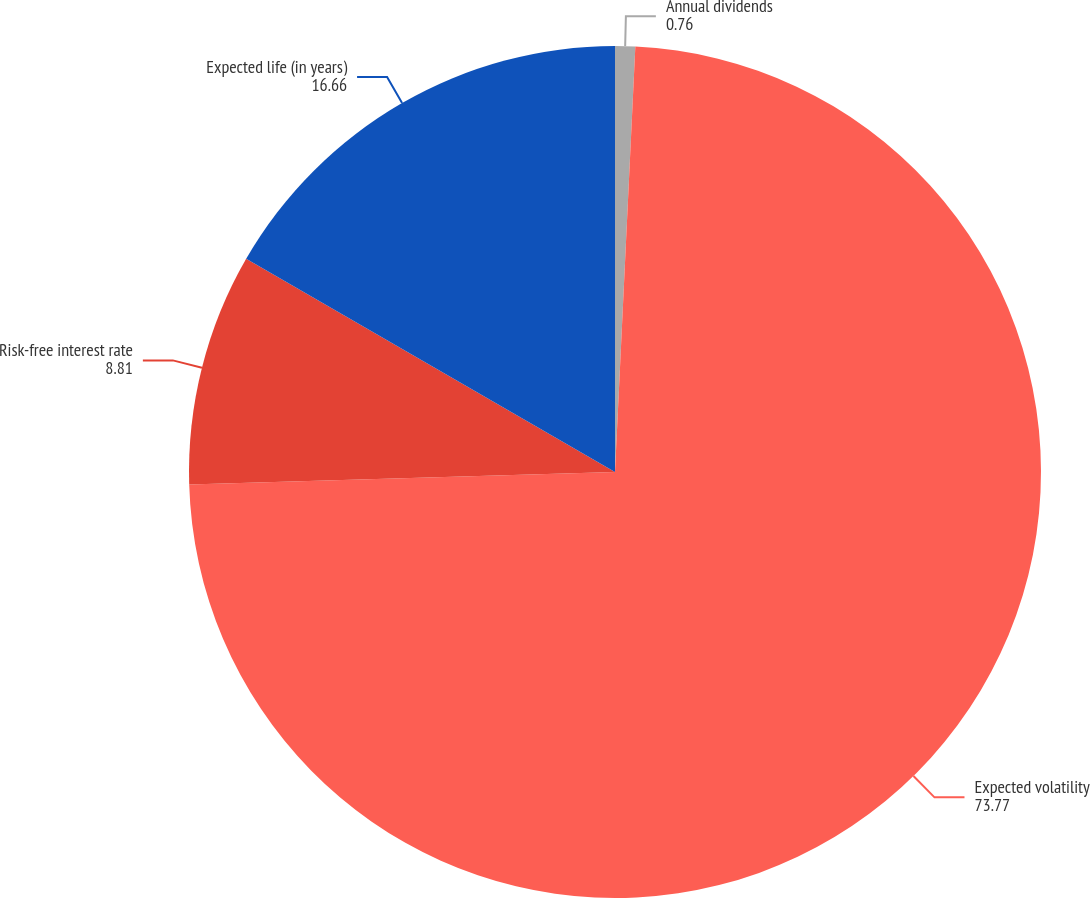Convert chart. <chart><loc_0><loc_0><loc_500><loc_500><pie_chart><fcel>Annual dividends<fcel>Expected volatility<fcel>Risk-free interest rate<fcel>Expected life (in years)<nl><fcel>0.76%<fcel>73.77%<fcel>8.81%<fcel>16.66%<nl></chart> 